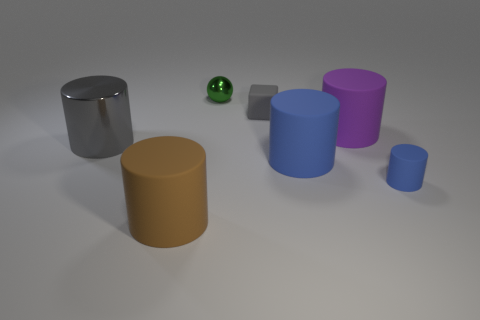Subtract 2 cylinders. How many cylinders are left? 3 Subtract all purple cylinders. How many cylinders are left? 4 Subtract all brown cylinders. How many cylinders are left? 4 Subtract all red cylinders. Subtract all cyan cubes. How many cylinders are left? 5 Add 1 balls. How many objects exist? 8 Subtract all cubes. How many objects are left? 6 Add 5 small cylinders. How many small cylinders exist? 6 Subtract 0 cyan cylinders. How many objects are left? 7 Subtract all gray rubber cubes. Subtract all brown cylinders. How many objects are left? 5 Add 3 blue things. How many blue things are left? 5 